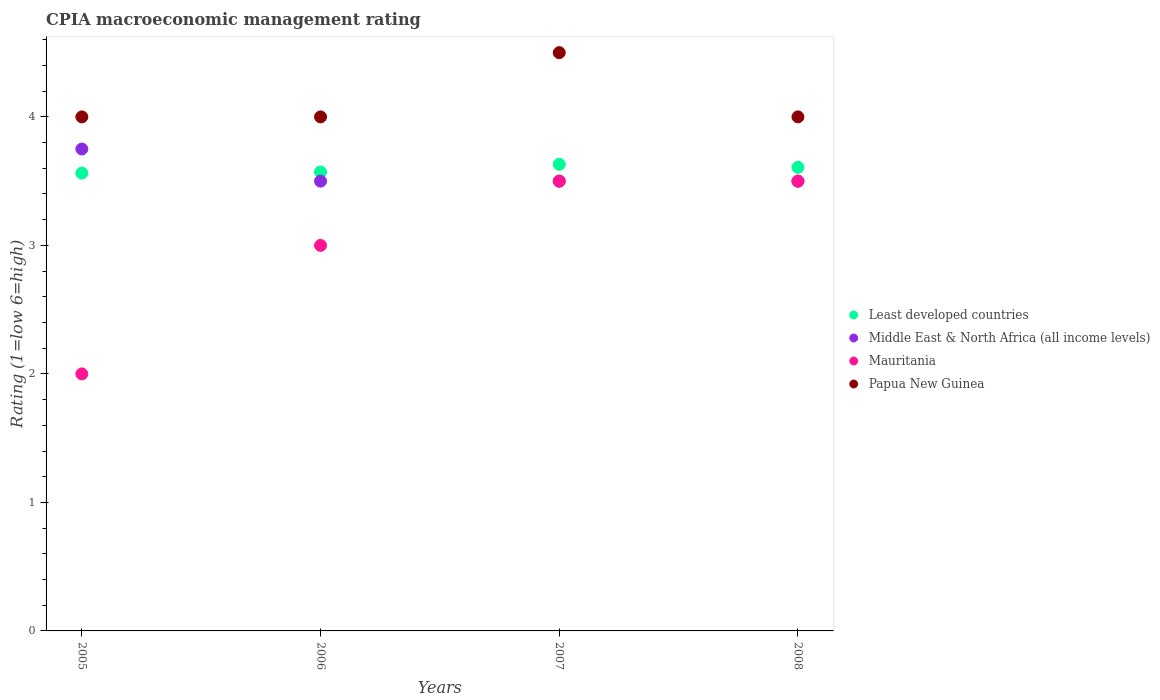How many different coloured dotlines are there?
Provide a succinct answer. 4. What is the CPIA rating in Middle East & North Africa (all income levels) in 2008?
Make the answer very short. 3.5. Across all years, what is the maximum CPIA rating in Mauritania?
Offer a very short reply. 3.5. In which year was the CPIA rating in Mauritania maximum?
Keep it short and to the point. 2007. What is the total CPIA rating in Middle East & North Africa (all income levels) in the graph?
Offer a terse response. 14.25. What is the difference between the CPIA rating in Mauritania in 2005 and that in 2006?
Your response must be concise. -1. What is the difference between the CPIA rating in Mauritania in 2006 and the CPIA rating in Least developed countries in 2005?
Ensure brevity in your answer.  -0.56. What is the average CPIA rating in Least developed countries per year?
Your response must be concise. 3.59. In the year 2006, what is the difference between the CPIA rating in Middle East & North Africa (all income levels) and CPIA rating in Papua New Guinea?
Provide a short and direct response. -0.5. In how many years, is the CPIA rating in Mauritania greater than 3.2?
Ensure brevity in your answer.  2. What is the ratio of the CPIA rating in Mauritania in 2006 to that in 2008?
Your answer should be very brief. 0.86. Is the CPIA rating in Middle East & North Africa (all income levels) in 2006 less than that in 2007?
Ensure brevity in your answer.  No. Is the difference between the CPIA rating in Middle East & North Africa (all income levels) in 2006 and 2008 greater than the difference between the CPIA rating in Papua New Guinea in 2006 and 2008?
Your response must be concise. No. What is the difference between the highest and the lowest CPIA rating in Middle East & North Africa (all income levels)?
Give a very brief answer. 0.25. In how many years, is the CPIA rating in Papua New Guinea greater than the average CPIA rating in Papua New Guinea taken over all years?
Keep it short and to the point. 1. Is it the case that in every year, the sum of the CPIA rating in Papua New Guinea and CPIA rating in Least developed countries  is greater than the CPIA rating in Mauritania?
Give a very brief answer. Yes. Is the CPIA rating in Papua New Guinea strictly greater than the CPIA rating in Least developed countries over the years?
Keep it short and to the point. Yes. How many dotlines are there?
Provide a short and direct response. 4. How many years are there in the graph?
Provide a succinct answer. 4. Are the values on the major ticks of Y-axis written in scientific E-notation?
Make the answer very short. No. Does the graph contain grids?
Your answer should be very brief. No. Where does the legend appear in the graph?
Your answer should be compact. Center right. How many legend labels are there?
Provide a succinct answer. 4. How are the legend labels stacked?
Your answer should be compact. Vertical. What is the title of the graph?
Provide a succinct answer. CPIA macroeconomic management rating. What is the label or title of the X-axis?
Keep it short and to the point. Years. What is the Rating (1=low 6=high) in Least developed countries in 2005?
Offer a very short reply. 3.56. What is the Rating (1=low 6=high) in Middle East & North Africa (all income levels) in 2005?
Provide a succinct answer. 3.75. What is the Rating (1=low 6=high) of Mauritania in 2005?
Ensure brevity in your answer.  2. What is the Rating (1=low 6=high) of Least developed countries in 2006?
Keep it short and to the point. 3.57. What is the Rating (1=low 6=high) in Middle East & North Africa (all income levels) in 2006?
Ensure brevity in your answer.  3.5. What is the Rating (1=low 6=high) of Mauritania in 2006?
Provide a succinct answer. 3. What is the Rating (1=low 6=high) in Papua New Guinea in 2006?
Your answer should be compact. 4. What is the Rating (1=low 6=high) of Least developed countries in 2007?
Your answer should be compact. 3.63. What is the Rating (1=low 6=high) in Middle East & North Africa (all income levels) in 2007?
Keep it short and to the point. 3.5. What is the Rating (1=low 6=high) in Papua New Guinea in 2007?
Offer a terse response. 4.5. What is the Rating (1=low 6=high) in Least developed countries in 2008?
Offer a very short reply. 3.61. What is the Rating (1=low 6=high) of Middle East & North Africa (all income levels) in 2008?
Your answer should be very brief. 3.5. What is the Rating (1=low 6=high) of Papua New Guinea in 2008?
Ensure brevity in your answer.  4. Across all years, what is the maximum Rating (1=low 6=high) in Least developed countries?
Give a very brief answer. 3.63. Across all years, what is the maximum Rating (1=low 6=high) in Middle East & North Africa (all income levels)?
Offer a terse response. 3.75. Across all years, what is the maximum Rating (1=low 6=high) of Mauritania?
Provide a short and direct response. 3.5. Across all years, what is the minimum Rating (1=low 6=high) in Least developed countries?
Your answer should be compact. 3.56. Across all years, what is the minimum Rating (1=low 6=high) in Middle East & North Africa (all income levels)?
Provide a short and direct response. 3.5. Across all years, what is the minimum Rating (1=low 6=high) in Mauritania?
Your response must be concise. 2. Across all years, what is the minimum Rating (1=low 6=high) of Papua New Guinea?
Give a very brief answer. 4. What is the total Rating (1=low 6=high) in Least developed countries in the graph?
Offer a very short reply. 14.37. What is the total Rating (1=low 6=high) of Middle East & North Africa (all income levels) in the graph?
Provide a short and direct response. 14.25. What is the difference between the Rating (1=low 6=high) in Least developed countries in 2005 and that in 2006?
Keep it short and to the point. -0.01. What is the difference between the Rating (1=low 6=high) in Middle East & North Africa (all income levels) in 2005 and that in 2006?
Offer a terse response. 0.25. What is the difference between the Rating (1=low 6=high) of Mauritania in 2005 and that in 2006?
Ensure brevity in your answer.  -1. What is the difference between the Rating (1=low 6=high) of Papua New Guinea in 2005 and that in 2006?
Offer a very short reply. 0. What is the difference between the Rating (1=low 6=high) in Least developed countries in 2005 and that in 2007?
Offer a very short reply. -0.07. What is the difference between the Rating (1=low 6=high) of Middle East & North Africa (all income levels) in 2005 and that in 2007?
Ensure brevity in your answer.  0.25. What is the difference between the Rating (1=low 6=high) of Least developed countries in 2005 and that in 2008?
Your response must be concise. -0.04. What is the difference between the Rating (1=low 6=high) of Middle East & North Africa (all income levels) in 2005 and that in 2008?
Your answer should be very brief. 0.25. What is the difference between the Rating (1=low 6=high) in Mauritania in 2005 and that in 2008?
Your answer should be very brief. -1.5. What is the difference between the Rating (1=low 6=high) of Least developed countries in 2006 and that in 2007?
Give a very brief answer. -0.06. What is the difference between the Rating (1=low 6=high) of Middle East & North Africa (all income levels) in 2006 and that in 2007?
Your answer should be very brief. 0. What is the difference between the Rating (1=low 6=high) of Mauritania in 2006 and that in 2007?
Your response must be concise. -0.5. What is the difference between the Rating (1=low 6=high) in Papua New Guinea in 2006 and that in 2007?
Offer a very short reply. -0.5. What is the difference between the Rating (1=low 6=high) in Least developed countries in 2006 and that in 2008?
Give a very brief answer. -0.04. What is the difference between the Rating (1=low 6=high) in Middle East & North Africa (all income levels) in 2006 and that in 2008?
Keep it short and to the point. 0. What is the difference between the Rating (1=low 6=high) in Least developed countries in 2007 and that in 2008?
Offer a very short reply. 0.02. What is the difference between the Rating (1=low 6=high) in Papua New Guinea in 2007 and that in 2008?
Your response must be concise. 0.5. What is the difference between the Rating (1=low 6=high) in Least developed countries in 2005 and the Rating (1=low 6=high) in Middle East & North Africa (all income levels) in 2006?
Offer a very short reply. 0.06. What is the difference between the Rating (1=low 6=high) in Least developed countries in 2005 and the Rating (1=low 6=high) in Mauritania in 2006?
Your response must be concise. 0.56. What is the difference between the Rating (1=low 6=high) of Least developed countries in 2005 and the Rating (1=low 6=high) of Papua New Guinea in 2006?
Your answer should be very brief. -0.44. What is the difference between the Rating (1=low 6=high) in Mauritania in 2005 and the Rating (1=low 6=high) in Papua New Guinea in 2006?
Keep it short and to the point. -2. What is the difference between the Rating (1=low 6=high) in Least developed countries in 2005 and the Rating (1=low 6=high) in Middle East & North Africa (all income levels) in 2007?
Give a very brief answer. 0.06. What is the difference between the Rating (1=low 6=high) of Least developed countries in 2005 and the Rating (1=low 6=high) of Mauritania in 2007?
Keep it short and to the point. 0.06. What is the difference between the Rating (1=low 6=high) in Least developed countries in 2005 and the Rating (1=low 6=high) in Papua New Guinea in 2007?
Offer a terse response. -0.94. What is the difference between the Rating (1=low 6=high) in Middle East & North Africa (all income levels) in 2005 and the Rating (1=low 6=high) in Mauritania in 2007?
Your response must be concise. 0.25. What is the difference between the Rating (1=low 6=high) in Middle East & North Africa (all income levels) in 2005 and the Rating (1=low 6=high) in Papua New Guinea in 2007?
Ensure brevity in your answer.  -0.75. What is the difference between the Rating (1=low 6=high) of Mauritania in 2005 and the Rating (1=low 6=high) of Papua New Guinea in 2007?
Keep it short and to the point. -2.5. What is the difference between the Rating (1=low 6=high) in Least developed countries in 2005 and the Rating (1=low 6=high) in Middle East & North Africa (all income levels) in 2008?
Your response must be concise. 0.06. What is the difference between the Rating (1=low 6=high) of Least developed countries in 2005 and the Rating (1=low 6=high) of Mauritania in 2008?
Ensure brevity in your answer.  0.06. What is the difference between the Rating (1=low 6=high) of Least developed countries in 2005 and the Rating (1=low 6=high) of Papua New Guinea in 2008?
Make the answer very short. -0.44. What is the difference between the Rating (1=low 6=high) in Mauritania in 2005 and the Rating (1=low 6=high) in Papua New Guinea in 2008?
Your answer should be very brief. -2. What is the difference between the Rating (1=low 6=high) in Least developed countries in 2006 and the Rating (1=low 6=high) in Middle East & North Africa (all income levels) in 2007?
Your answer should be compact. 0.07. What is the difference between the Rating (1=low 6=high) of Least developed countries in 2006 and the Rating (1=low 6=high) of Mauritania in 2007?
Make the answer very short. 0.07. What is the difference between the Rating (1=low 6=high) of Least developed countries in 2006 and the Rating (1=low 6=high) of Papua New Guinea in 2007?
Keep it short and to the point. -0.93. What is the difference between the Rating (1=low 6=high) of Least developed countries in 2006 and the Rating (1=low 6=high) of Middle East & North Africa (all income levels) in 2008?
Offer a very short reply. 0.07. What is the difference between the Rating (1=low 6=high) in Least developed countries in 2006 and the Rating (1=low 6=high) in Mauritania in 2008?
Provide a succinct answer. 0.07. What is the difference between the Rating (1=low 6=high) of Least developed countries in 2006 and the Rating (1=low 6=high) of Papua New Guinea in 2008?
Your answer should be compact. -0.43. What is the difference between the Rating (1=low 6=high) in Middle East & North Africa (all income levels) in 2006 and the Rating (1=low 6=high) in Mauritania in 2008?
Offer a very short reply. 0. What is the difference between the Rating (1=low 6=high) of Mauritania in 2006 and the Rating (1=low 6=high) of Papua New Guinea in 2008?
Offer a very short reply. -1. What is the difference between the Rating (1=low 6=high) of Least developed countries in 2007 and the Rating (1=low 6=high) of Middle East & North Africa (all income levels) in 2008?
Make the answer very short. 0.13. What is the difference between the Rating (1=low 6=high) in Least developed countries in 2007 and the Rating (1=low 6=high) in Mauritania in 2008?
Your answer should be compact. 0.13. What is the difference between the Rating (1=low 6=high) in Least developed countries in 2007 and the Rating (1=low 6=high) in Papua New Guinea in 2008?
Provide a short and direct response. -0.37. What is the difference between the Rating (1=low 6=high) of Middle East & North Africa (all income levels) in 2007 and the Rating (1=low 6=high) of Mauritania in 2008?
Make the answer very short. 0. What is the average Rating (1=low 6=high) in Least developed countries per year?
Offer a terse response. 3.59. What is the average Rating (1=low 6=high) in Middle East & North Africa (all income levels) per year?
Give a very brief answer. 3.56. What is the average Rating (1=low 6=high) in Papua New Guinea per year?
Your response must be concise. 4.12. In the year 2005, what is the difference between the Rating (1=low 6=high) of Least developed countries and Rating (1=low 6=high) of Middle East & North Africa (all income levels)?
Keep it short and to the point. -0.19. In the year 2005, what is the difference between the Rating (1=low 6=high) in Least developed countries and Rating (1=low 6=high) in Mauritania?
Offer a very short reply. 1.56. In the year 2005, what is the difference between the Rating (1=low 6=high) of Least developed countries and Rating (1=low 6=high) of Papua New Guinea?
Your answer should be very brief. -0.44. In the year 2005, what is the difference between the Rating (1=low 6=high) of Middle East & North Africa (all income levels) and Rating (1=low 6=high) of Mauritania?
Provide a succinct answer. 1.75. In the year 2005, what is the difference between the Rating (1=low 6=high) in Middle East & North Africa (all income levels) and Rating (1=low 6=high) in Papua New Guinea?
Offer a terse response. -0.25. In the year 2006, what is the difference between the Rating (1=low 6=high) in Least developed countries and Rating (1=low 6=high) in Middle East & North Africa (all income levels)?
Provide a succinct answer. 0.07. In the year 2006, what is the difference between the Rating (1=low 6=high) in Least developed countries and Rating (1=low 6=high) in Mauritania?
Make the answer very short. 0.57. In the year 2006, what is the difference between the Rating (1=low 6=high) in Least developed countries and Rating (1=low 6=high) in Papua New Guinea?
Offer a terse response. -0.43. In the year 2007, what is the difference between the Rating (1=low 6=high) of Least developed countries and Rating (1=low 6=high) of Middle East & North Africa (all income levels)?
Provide a succinct answer. 0.13. In the year 2007, what is the difference between the Rating (1=low 6=high) of Least developed countries and Rating (1=low 6=high) of Mauritania?
Ensure brevity in your answer.  0.13. In the year 2007, what is the difference between the Rating (1=low 6=high) in Least developed countries and Rating (1=low 6=high) in Papua New Guinea?
Your response must be concise. -0.87. In the year 2007, what is the difference between the Rating (1=low 6=high) of Middle East & North Africa (all income levels) and Rating (1=low 6=high) of Mauritania?
Provide a short and direct response. 0. In the year 2007, what is the difference between the Rating (1=low 6=high) in Middle East & North Africa (all income levels) and Rating (1=low 6=high) in Papua New Guinea?
Your response must be concise. -1. In the year 2008, what is the difference between the Rating (1=low 6=high) of Least developed countries and Rating (1=low 6=high) of Middle East & North Africa (all income levels)?
Ensure brevity in your answer.  0.11. In the year 2008, what is the difference between the Rating (1=low 6=high) in Least developed countries and Rating (1=low 6=high) in Mauritania?
Provide a short and direct response. 0.11. In the year 2008, what is the difference between the Rating (1=low 6=high) of Least developed countries and Rating (1=low 6=high) of Papua New Guinea?
Ensure brevity in your answer.  -0.39. In the year 2008, what is the difference between the Rating (1=low 6=high) in Middle East & North Africa (all income levels) and Rating (1=low 6=high) in Mauritania?
Offer a very short reply. 0. What is the ratio of the Rating (1=low 6=high) of Middle East & North Africa (all income levels) in 2005 to that in 2006?
Provide a succinct answer. 1.07. What is the ratio of the Rating (1=low 6=high) of Least developed countries in 2005 to that in 2007?
Ensure brevity in your answer.  0.98. What is the ratio of the Rating (1=low 6=high) in Middle East & North Africa (all income levels) in 2005 to that in 2007?
Offer a terse response. 1.07. What is the ratio of the Rating (1=low 6=high) in Papua New Guinea in 2005 to that in 2007?
Your answer should be very brief. 0.89. What is the ratio of the Rating (1=low 6=high) in Least developed countries in 2005 to that in 2008?
Your answer should be very brief. 0.99. What is the ratio of the Rating (1=low 6=high) of Middle East & North Africa (all income levels) in 2005 to that in 2008?
Your response must be concise. 1.07. What is the ratio of the Rating (1=low 6=high) of Mauritania in 2005 to that in 2008?
Keep it short and to the point. 0.57. What is the ratio of the Rating (1=low 6=high) in Least developed countries in 2006 to that in 2007?
Ensure brevity in your answer.  0.98. What is the ratio of the Rating (1=low 6=high) of Middle East & North Africa (all income levels) in 2006 to that in 2007?
Your answer should be very brief. 1. What is the ratio of the Rating (1=low 6=high) of Papua New Guinea in 2006 to that in 2007?
Your answer should be very brief. 0.89. What is the ratio of the Rating (1=low 6=high) in Middle East & North Africa (all income levels) in 2006 to that in 2008?
Offer a very short reply. 1. What is the ratio of the Rating (1=low 6=high) of Papua New Guinea in 2006 to that in 2008?
Ensure brevity in your answer.  1. What is the ratio of the Rating (1=low 6=high) in Least developed countries in 2007 to that in 2008?
Ensure brevity in your answer.  1.01. What is the ratio of the Rating (1=low 6=high) in Mauritania in 2007 to that in 2008?
Your answer should be compact. 1. What is the difference between the highest and the second highest Rating (1=low 6=high) in Least developed countries?
Your response must be concise. 0.02. What is the difference between the highest and the second highest Rating (1=low 6=high) of Middle East & North Africa (all income levels)?
Ensure brevity in your answer.  0.25. What is the difference between the highest and the second highest Rating (1=low 6=high) in Mauritania?
Offer a very short reply. 0. What is the difference between the highest and the second highest Rating (1=low 6=high) in Papua New Guinea?
Make the answer very short. 0.5. What is the difference between the highest and the lowest Rating (1=low 6=high) of Least developed countries?
Give a very brief answer. 0.07. What is the difference between the highest and the lowest Rating (1=low 6=high) of Mauritania?
Your answer should be compact. 1.5. 